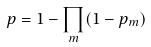Convert formula to latex. <formula><loc_0><loc_0><loc_500><loc_500>p = 1 - \prod _ { m } ( 1 - p _ { m } )</formula> 